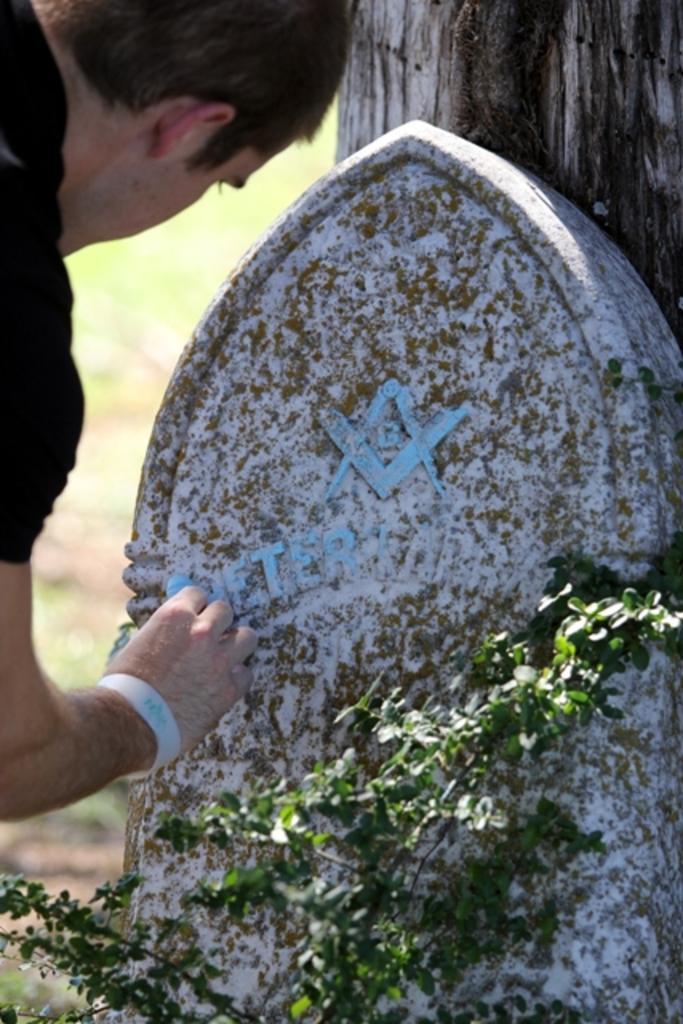Could you give a brief overview of what you see in this image? In this image we can see a person on the left side. Near to him there is a stone with something written. Also there is a plant. In the background it is blur. Back of the stone there is a wooden piece. 